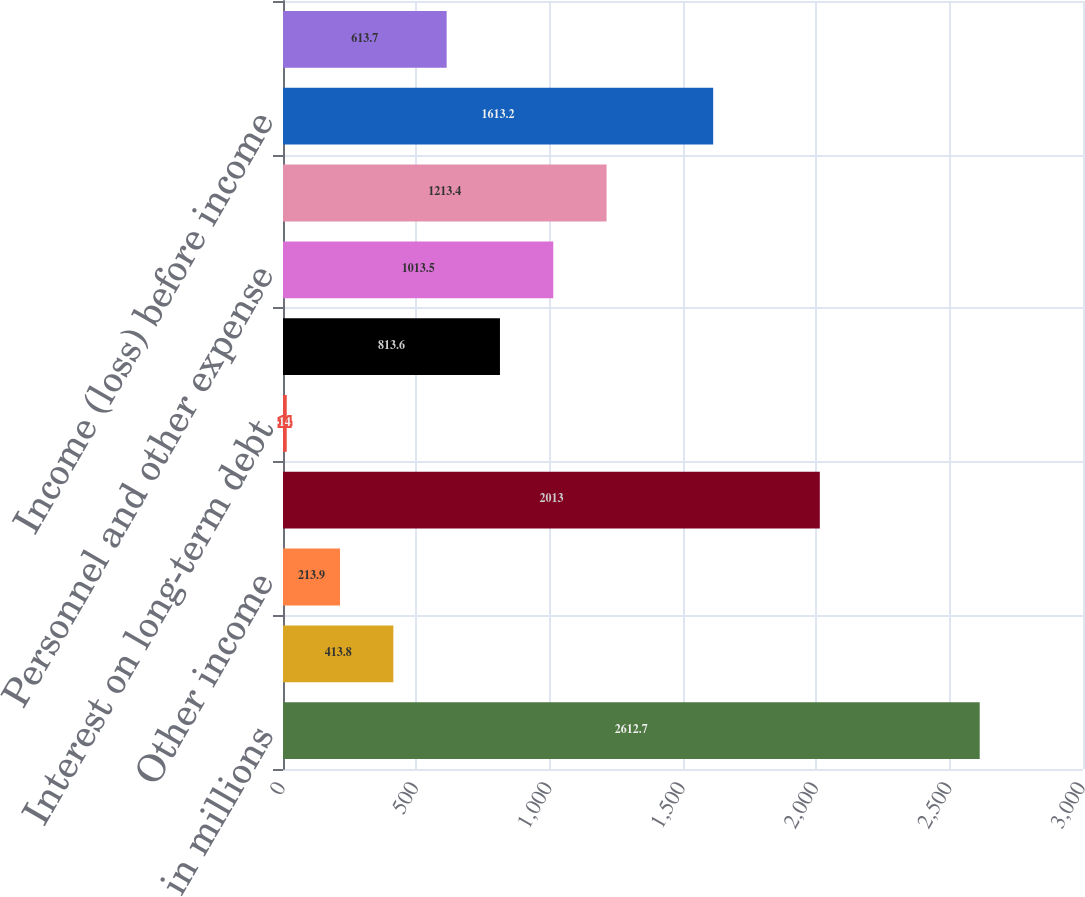Convert chart to OTSL. <chart><loc_0><loc_0><loc_500><loc_500><bar_chart><fcel>in millions<fcel>Interest income from<fcel>Other income<fcel>Total income<fcel>Interest on long-term debt<fcel>Interest on other borrowed<fcel>Personnel and other expense<fcel>Total expense<fcel>Income (loss) before income<fcel>Income tax (expense) benefit<nl><fcel>2612.7<fcel>413.8<fcel>213.9<fcel>2013<fcel>14<fcel>813.6<fcel>1013.5<fcel>1213.4<fcel>1613.2<fcel>613.7<nl></chart> 